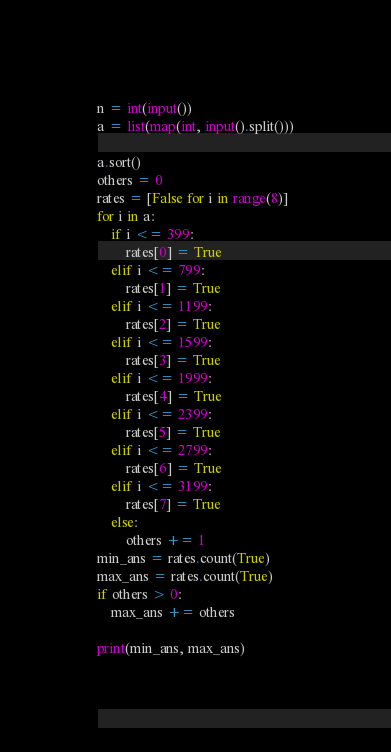Convert code to text. <code><loc_0><loc_0><loc_500><loc_500><_Python_>n = int(input())
a = list(map(int, input().split()))

a.sort()
others = 0
rates = [False for i in range(8)]
for i in a:
    if i <= 399:
        rates[0] = True
    elif i <= 799:
        rates[1] = True
    elif i <= 1199:
        rates[2] = True
    elif i <= 1599:
        rates[3] = True
    elif i <= 1999:
        rates[4] = True
    elif i <= 2399:
        rates[5] = True
    elif i <= 2799:
        rates[6] = True
    elif i <= 3199:
        rates[7] = True
    else:
        others += 1
min_ans = rates.count(True)
max_ans = rates.count(True)
if others > 0:
    max_ans += others

print(min_ans, max_ans)</code> 